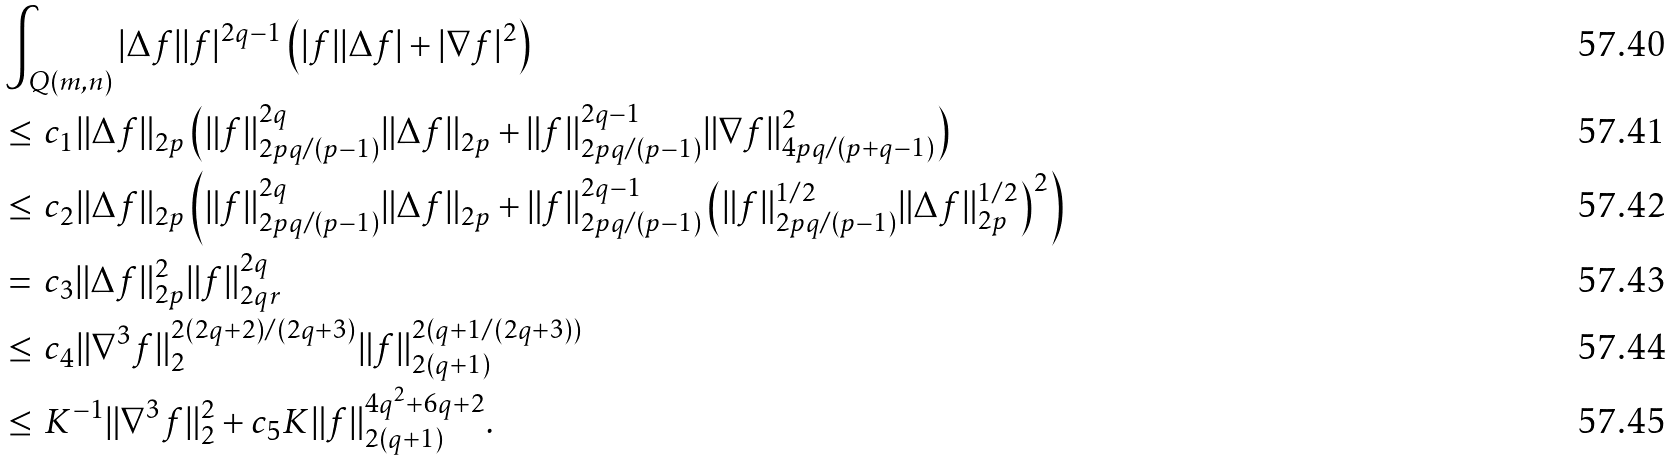Convert formula to latex. <formula><loc_0><loc_0><loc_500><loc_500>& \int _ { Q ( m , n ) } | \Delta f | | f | ^ { 2 q - 1 } \left ( | f | | \Delta f | + | \nabla f | ^ { 2 } \right ) \\ & \leq \, c _ { 1 } \| \Delta f \| _ { 2 p } \left ( \| f \| _ { 2 p q / ( p - 1 ) } ^ { 2 q } \| \Delta f \| _ { 2 p } + \| f \| _ { 2 p q / ( p - 1 ) } ^ { 2 q - 1 } \| \nabla f \| ^ { 2 } _ { 4 p q / ( p + q - 1 ) } \right ) \\ & \leq \, c _ { 2 } \| \Delta f \| _ { 2 p } \left ( \| f \| _ { 2 p q / ( p - 1 ) } ^ { 2 q } \| \Delta f \| _ { 2 p } + \| f \| _ { 2 p q / ( p - 1 ) } ^ { 2 q - 1 } \left ( \| f \| ^ { 1 / 2 } _ { 2 p q / ( p - 1 ) } \| \Delta f \| ^ { 1 / 2 } _ { 2 p } \right ) ^ { 2 } \right ) \\ & = \, c _ { 3 } \| \Delta f \| _ { 2 p } ^ { 2 } \| f \| _ { 2 q r } ^ { 2 q } \\ & \leq \, c _ { 4 } \| \nabla ^ { 3 } f \| _ { 2 } ^ { 2 ( 2 q + 2 ) / ( 2 q + 3 ) } \| f \| _ { 2 ( q + 1 ) } ^ { 2 ( q + 1 / ( 2 q + 3 ) ) } \\ & \leq \, K ^ { - 1 } \| \nabla ^ { 3 } f \| _ { 2 } ^ { 2 } + c _ { 5 } K \| f \| _ { 2 ( q + 1 ) } ^ { 4 q ^ { 2 } + 6 q + 2 } .</formula> 